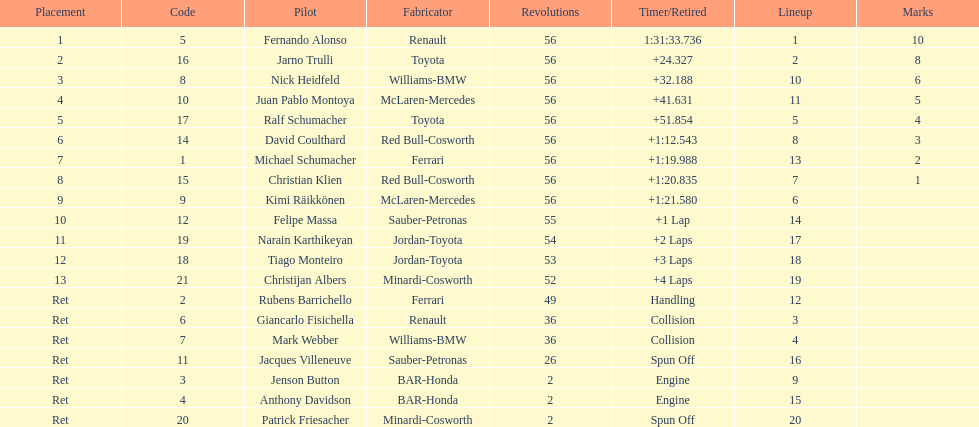Write the full table. {'header': ['Placement', 'Code', 'Pilot', 'Fabricator', 'Revolutions', 'Timer/Retired', 'Lineup', 'Marks'], 'rows': [['1', '5', 'Fernando Alonso', 'Renault', '56', '1:31:33.736', '1', '10'], ['2', '16', 'Jarno Trulli', 'Toyota', '56', '+24.327', '2', '8'], ['3', '8', 'Nick Heidfeld', 'Williams-BMW', '56', '+32.188', '10', '6'], ['4', '10', 'Juan Pablo Montoya', 'McLaren-Mercedes', '56', '+41.631', '11', '5'], ['5', '17', 'Ralf Schumacher', 'Toyota', '56', '+51.854', '5', '4'], ['6', '14', 'David Coulthard', 'Red Bull-Cosworth', '56', '+1:12.543', '8', '3'], ['7', '1', 'Michael Schumacher', 'Ferrari', '56', '+1:19.988', '13', '2'], ['8', '15', 'Christian Klien', 'Red Bull-Cosworth', '56', '+1:20.835', '7', '1'], ['9', '9', 'Kimi Räikkönen', 'McLaren-Mercedes', '56', '+1:21.580', '6', ''], ['10', '12', 'Felipe Massa', 'Sauber-Petronas', '55', '+1 Lap', '14', ''], ['11', '19', 'Narain Karthikeyan', 'Jordan-Toyota', '54', '+2 Laps', '17', ''], ['12', '18', 'Tiago Monteiro', 'Jordan-Toyota', '53', '+3 Laps', '18', ''], ['13', '21', 'Christijan Albers', 'Minardi-Cosworth', '52', '+4 Laps', '19', ''], ['Ret', '2', 'Rubens Barrichello', 'Ferrari', '49', 'Handling', '12', ''], ['Ret', '6', 'Giancarlo Fisichella', 'Renault', '36', 'Collision', '3', ''], ['Ret', '7', 'Mark Webber', 'Williams-BMW', '36', 'Collision', '4', ''], ['Ret', '11', 'Jacques Villeneuve', 'Sauber-Petronas', '26', 'Spun Off', '16', ''], ['Ret', '3', 'Jenson Button', 'BAR-Honda', '2', 'Engine', '9', ''], ['Ret', '4', 'Anthony Davidson', 'BAR-Honda', '2', 'Engine', '15', ''], ['Ret', '20', 'Patrick Friesacher', 'Minardi-Cosworth', '2', 'Spun Off', '20', '']]} How many germans finished in the top five? 2. 